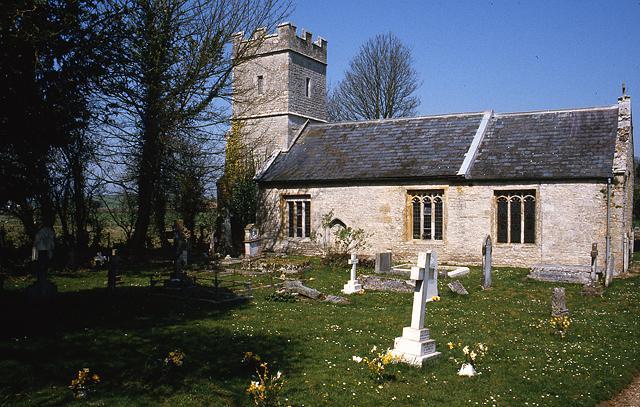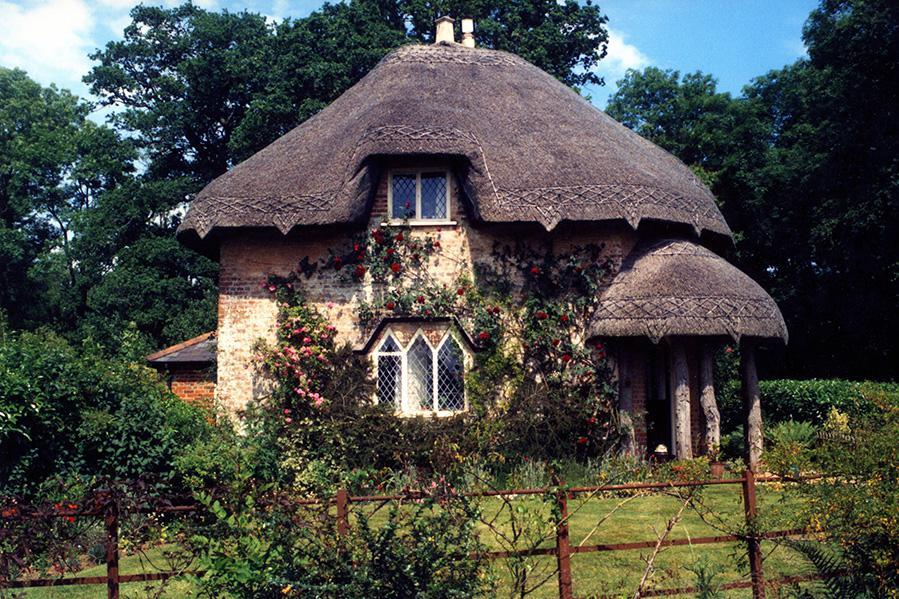The first image is the image on the left, the second image is the image on the right. Given the left and right images, does the statement "One image shows a row of at least four rectangular white buildings with dark gray roofs to the left of a paved road, and the other image shows one rectangular white building with a dark gray roof." hold true? Answer yes or no. No. The first image is the image on the left, the second image is the image on the right. Examine the images to the left and right. Is the description "A street passes near a row of houses in the image on the left." accurate? Answer yes or no. No. 